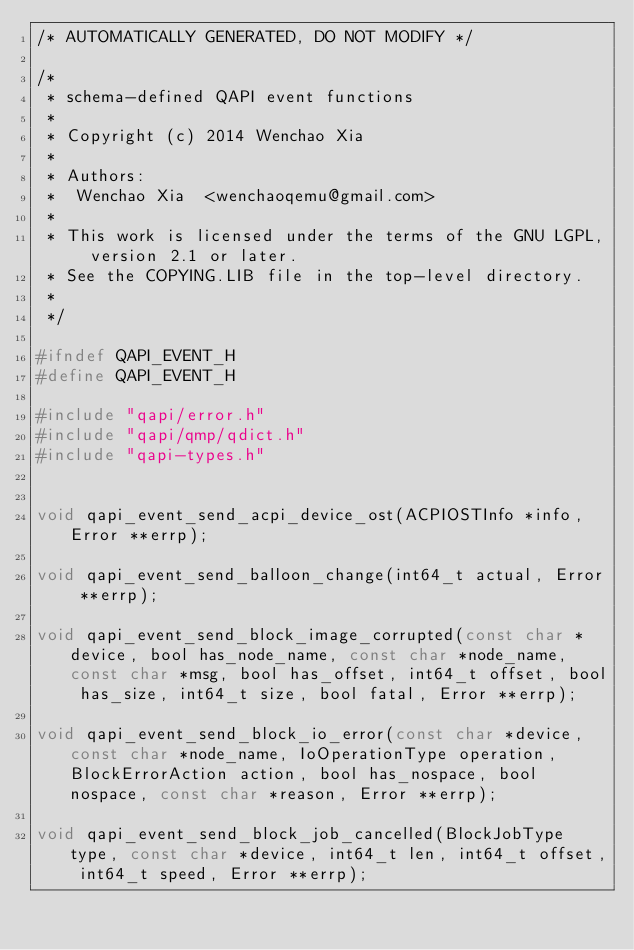<code> <loc_0><loc_0><loc_500><loc_500><_C_>/* AUTOMATICALLY GENERATED, DO NOT MODIFY */

/*
 * schema-defined QAPI event functions
 *
 * Copyright (c) 2014 Wenchao Xia
 *
 * Authors:
 *  Wenchao Xia  <wenchaoqemu@gmail.com>
 *
 * This work is licensed under the terms of the GNU LGPL, version 2.1 or later.
 * See the COPYING.LIB file in the top-level directory.
 *
 */

#ifndef QAPI_EVENT_H
#define QAPI_EVENT_H

#include "qapi/error.h"
#include "qapi/qmp/qdict.h"
#include "qapi-types.h"


void qapi_event_send_acpi_device_ost(ACPIOSTInfo *info, Error **errp);

void qapi_event_send_balloon_change(int64_t actual, Error **errp);

void qapi_event_send_block_image_corrupted(const char *device, bool has_node_name, const char *node_name, const char *msg, bool has_offset, int64_t offset, bool has_size, int64_t size, bool fatal, Error **errp);

void qapi_event_send_block_io_error(const char *device, const char *node_name, IoOperationType operation, BlockErrorAction action, bool has_nospace, bool nospace, const char *reason, Error **errp);

void qapi_event_send_block_job_cancelled(BlockJobType type, const char *device, int64_t len, int64_t offset, int64_t speed, Error **errp);
</code> 